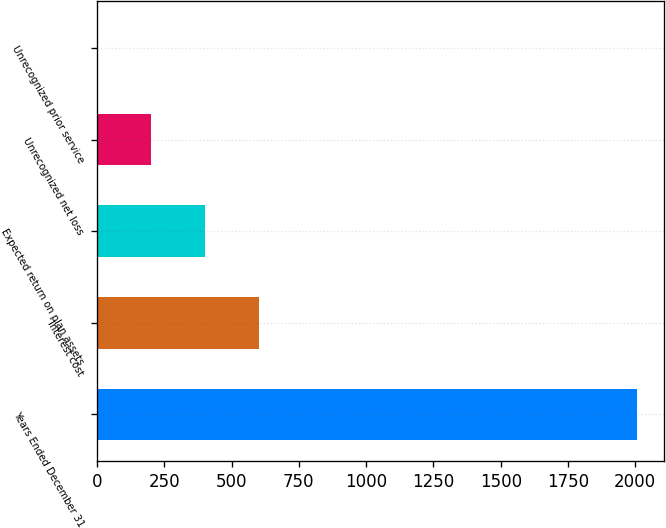Convert chart to OTSL. <chart><loc_0><loc_0><loc_500><loc_500><bar_chart><fcel>Years Ended December 31<fcel>Interest cost<fcel>Expected return on plan assets<fcel>Unrecognized net loss<fcel>Unrecognized prior service<nl><fcel>2006<fcel>603.2<fcel>402.8<fcel>202.4<fcel>2<nl></chart> 